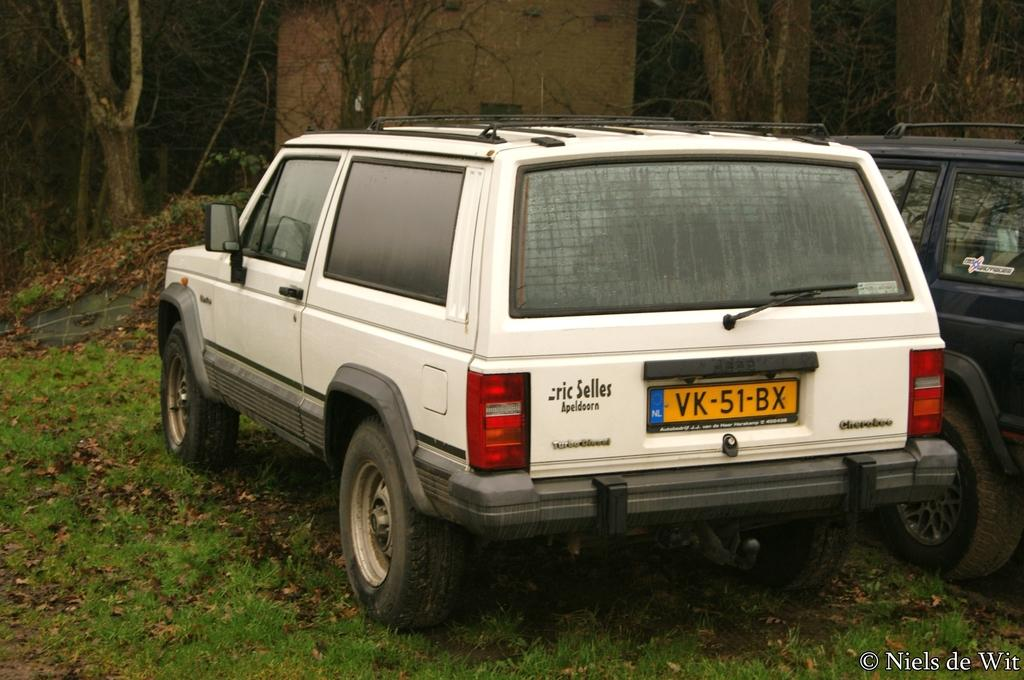What objects are placed on the ground in the image? There are cars placed on the ground in the image. What type of vegetation can be seen in the image? There is grass visible in the image. What natural feature is present in the image? There is a group of trees in the image. What type of structure is visible in the image? There is a building in the image. What type of payment is accepted at the building in the image? There is no information about payment in the image; it only shows cars, grass, trees, and a building. 